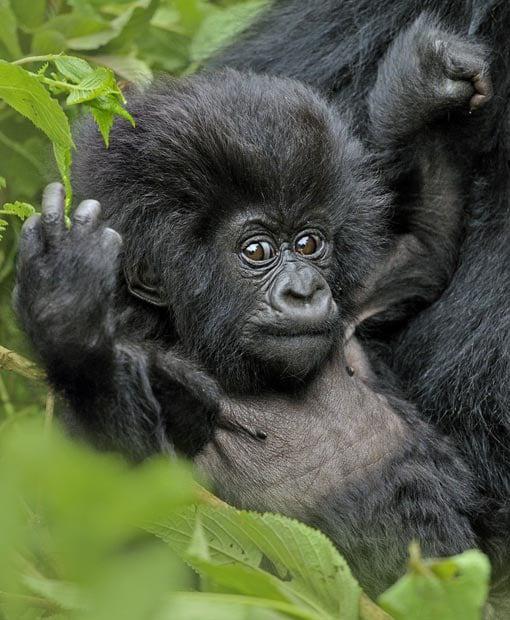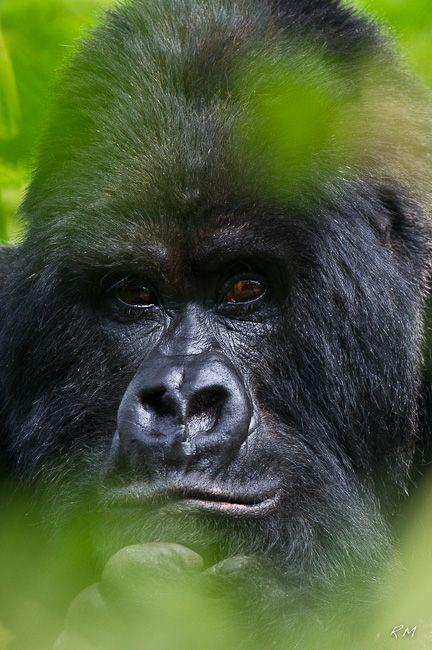The first image is the image on the left, the second image is the image on the right. Given the left and right images, does the statement "At least one image has a gorilla with an open mouth." hold true? Answer yes or no. No. The first image is the image on the left, the second image is the image on the right. For the images shown, is this caption "In one of the image there is a baby gorilla next to an adult gorilla." true? Answer yes or no. Yes. 